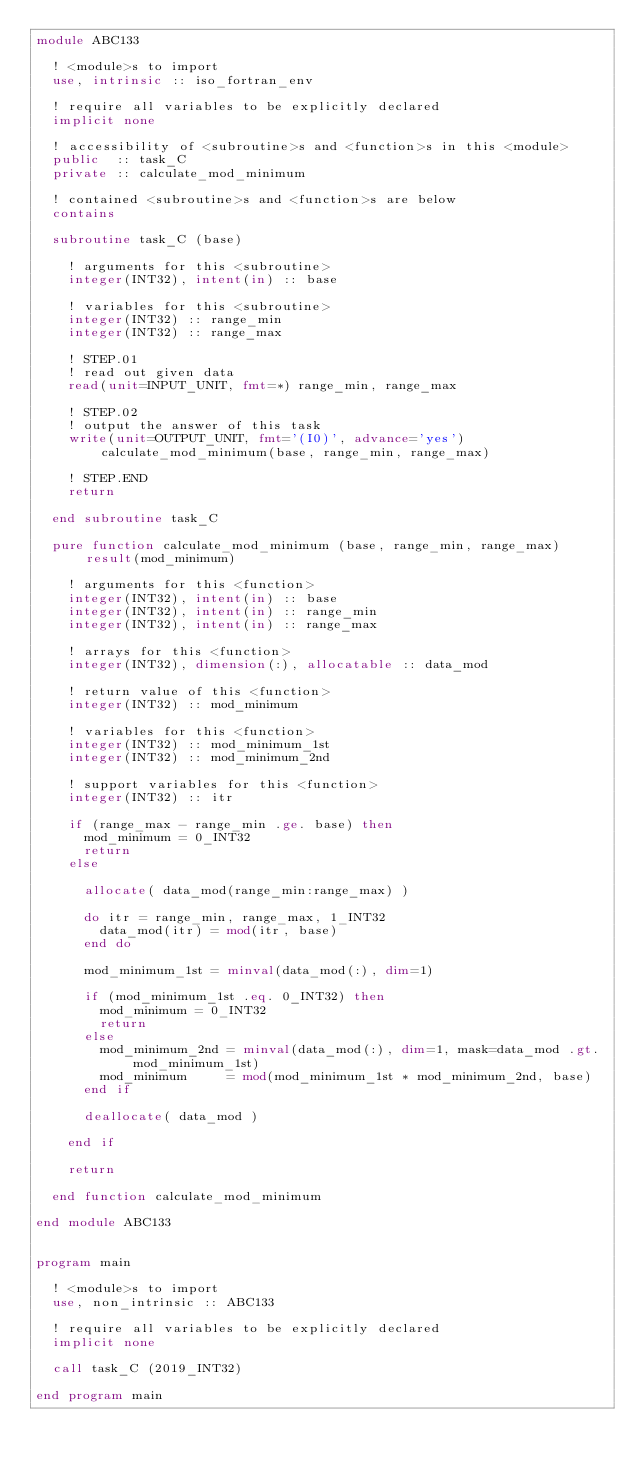Convert code to text. <code><loc_0><loc_0><loc_500><loc_500><_FORTRAN_>module ABC133

  ! <module>s to import
  use, intrinsic :: iso_fortran_env

  ! require all variables to be explicitly declared
  implicit none

  ! accessibility of <subroutine>s and <function>s in this <module>
  public  :: task_C
  private :: calculate_mod_minimum

  ! contained <subroutine>s and <function>s are below
  contains

  subroutine task_C (base)

    ! arguments for this <subroutine>
    integer(INT32), intent(in) :: base

    ! variables for this <subroutine>
    integer(INT32) :: range_min
    integer(INT32) :: range_max

    ! STEP.01
    ! read out given data
    read(unit=INPUT_UNIT, fmt=*) range_min, range_max

    ! STEP.02
    ! output the answer of this task
    write(unit=OUTPUT_UNIT, fmt='(I0)', advance='yes') calculate_mod_minimum(base, range_min, range_max)

    ! STEP.END
    return

  end subroutine task_C

  pure function calculate_mod_minimum (base, range_min, range_max) result(mod_minimum)

    ! arguments for this <function>
    integer(INT32), intent(in) :: base
    integer(INT32), intent(in) :: range_min
    integer(INT32), intent(in) :: range_max

    ! arrays for this <function>
    integer(INT32), dimension(:), allocatable :: data_mod

    ! return value of this <function>
    integer(INT32) :: mod_minimum

    ! variables for this <function>
    integer(INT32) :: mod_minimum_1st
    integer(INT32) :: mod_minimum_2nd

    ! support variables for this <function>
    integer(INT32) :: itr

    if (range_max - range_min .ge. base) then
      mod_minimum = 0_INT32
      return
    else

      allocate( data_mod(range_min:range_max) )

      do itr = range_min, range_max, 1_INT32
        data_mod(itr) = mod(itr, base)
      end do

      mod_minimum_1st = minval(data_mod(:), dim=1)

      if (mod_minimum_1st .eq. 0_INT32) then
        mod_minimum = 0_INT32
        return
      else
        mod_minimum_2nd = minval(data_mod(:), dim=1, mask=data_mod .gt. mod_minimum_1st)
        mod_minimum     = mod(mod_minimum_1st * mod_minimum_2nd, base)
      end if

      deallocate( data_mod )

    end if

    return

  end function calculate_mod_minimum

end module ABC133


program main

  ! <module>s to import
  use, non_intrinsic :: ABC133

  ! require all variables to be explicitly declared
  implicit none

  call task_C (2019_INT32)

end program main</code> 